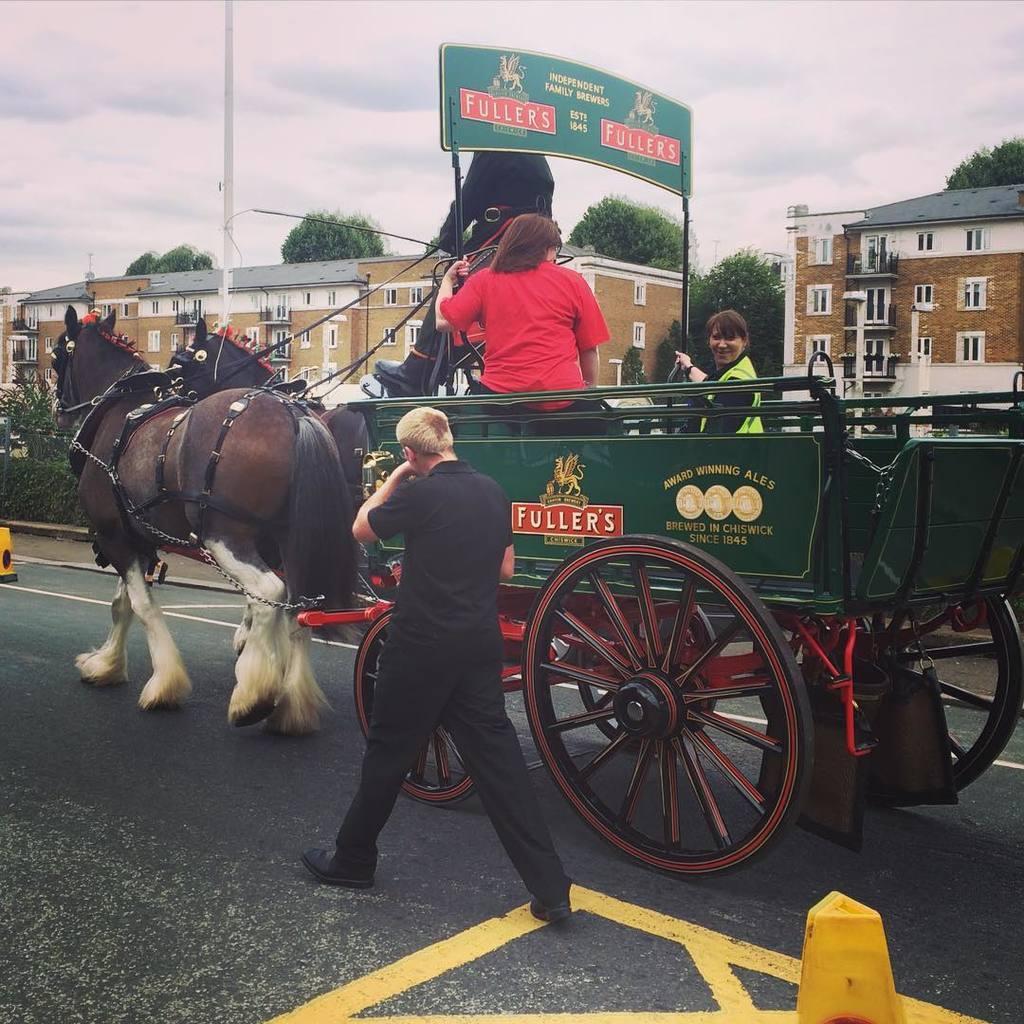Please provide a concise description of this image. In this image I can see two horses in brown color. I can also see two persons sitting in the cart, in front the person is wearing black color dress and walking on the road. Background I can see few buildings in brown color, trees in green color and the sky is in white color. 